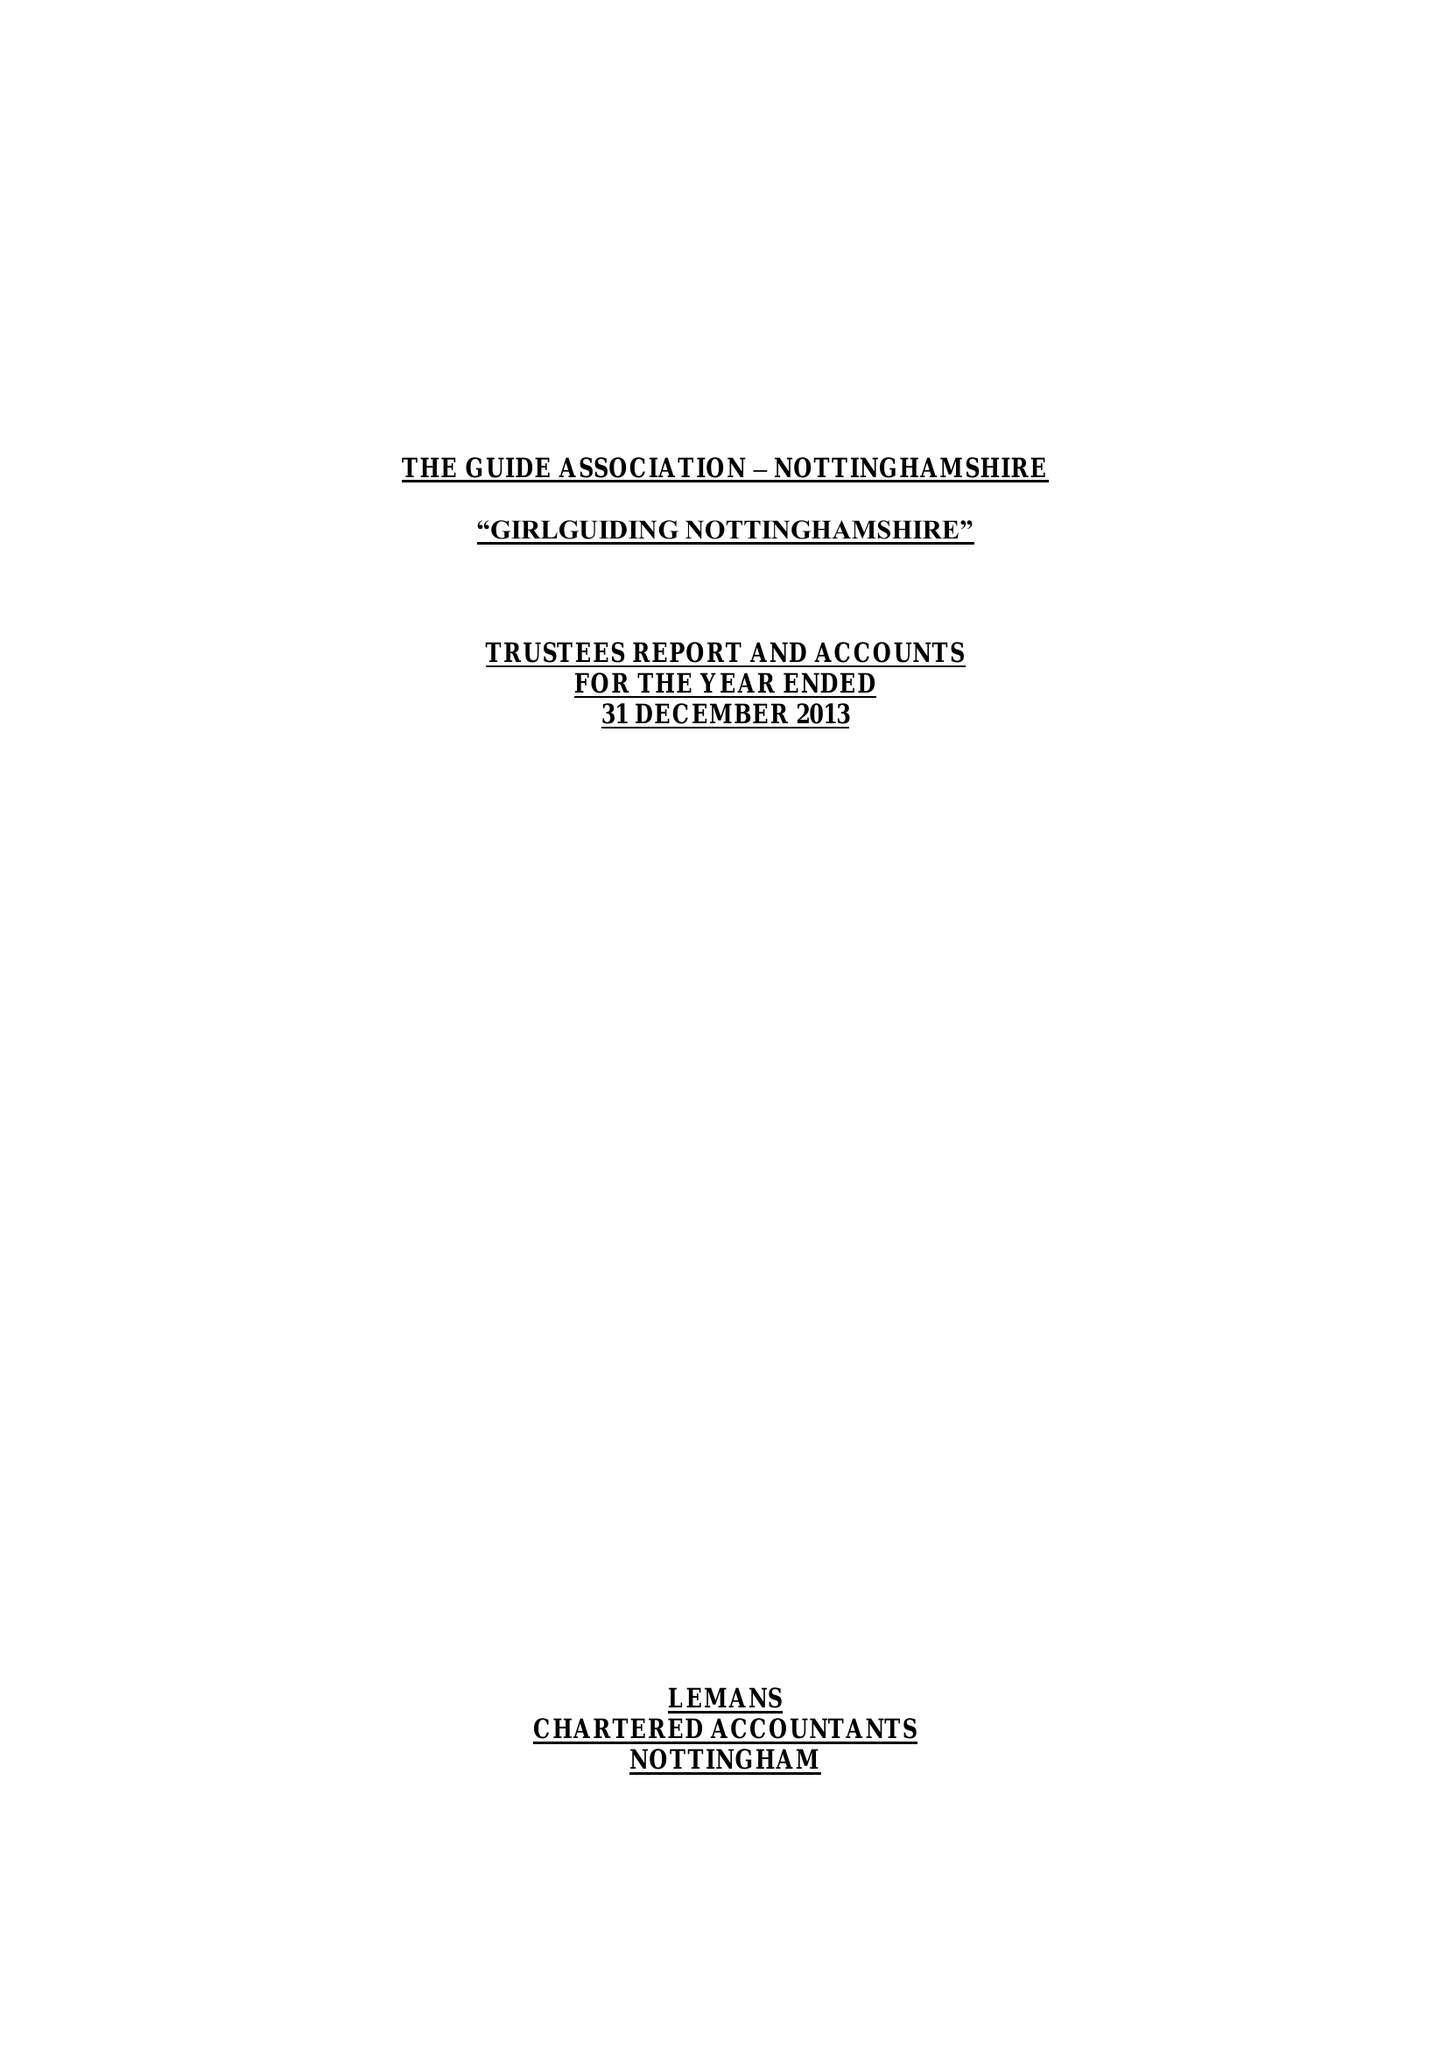What is the value for the address__post_town?
Answer the question using a single word or phrase. NOTTINGHAM 